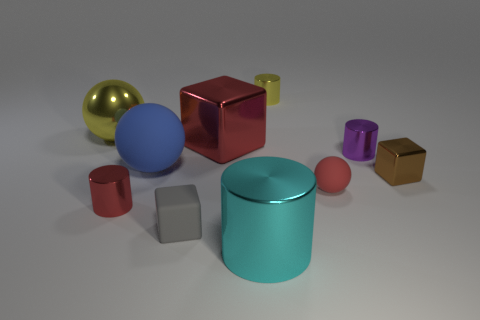What materials do these objects seem to be made from? The objects appear to have a metallic or plastic-like finish, with reflective surfaces suggesting they could be either polished metal or smooth plastic. 